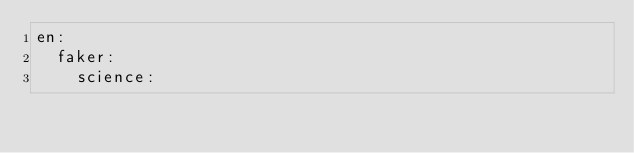<code> <loc_0><loc_0><loc_500><loc_500><_YAML_>en:
  faker:
    science:</code> 